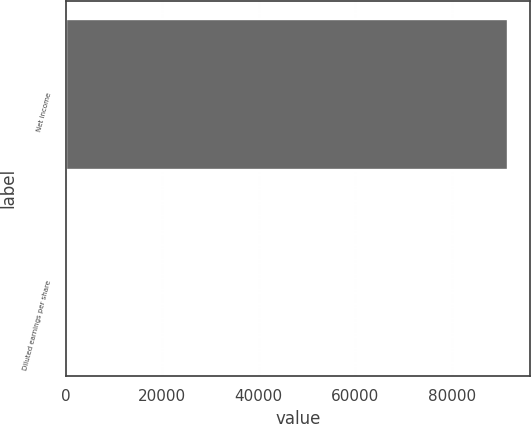Convert chart. <chart><loc_0><loc_0><loc_500><loc_500><bar_chart><fcel>Net income<fcel>Diluted earnings per share<nl><fcel>91696<fcel>1.28<nl></chart> 